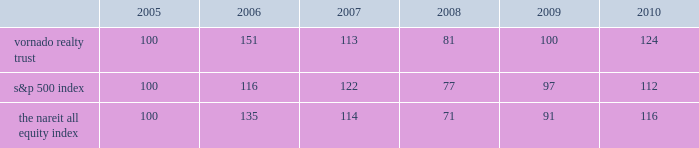Performance graph the following graph is a comparison of the five-year cumulative return of our common shares , the standard & poor 2019s 500 index ( the 201cs&p 500 index 201d ) and the national association of real estate investment trusts 2019 ( 201cnareit 201d ) all equity index ( excluding health care real estate investment trusts ) , a peer group index .
The graph assumes that $ 100 was invested on december 31 , 2005 in our common shares , the s&p 500 index and the nareit all equity index and that all dividends were reinvested without the payment of any commissions .
There can be no assurance that the performance of our shares will continue in line with the same or similar trends depicted in the graph below. .

What was the percentage growth of the vornado realty trust from 2005 to 2006? 
Rationale: the percentage growth is the growth amount divided by the base amount
Computations: (151 - 100)
Answer: 51.0. 